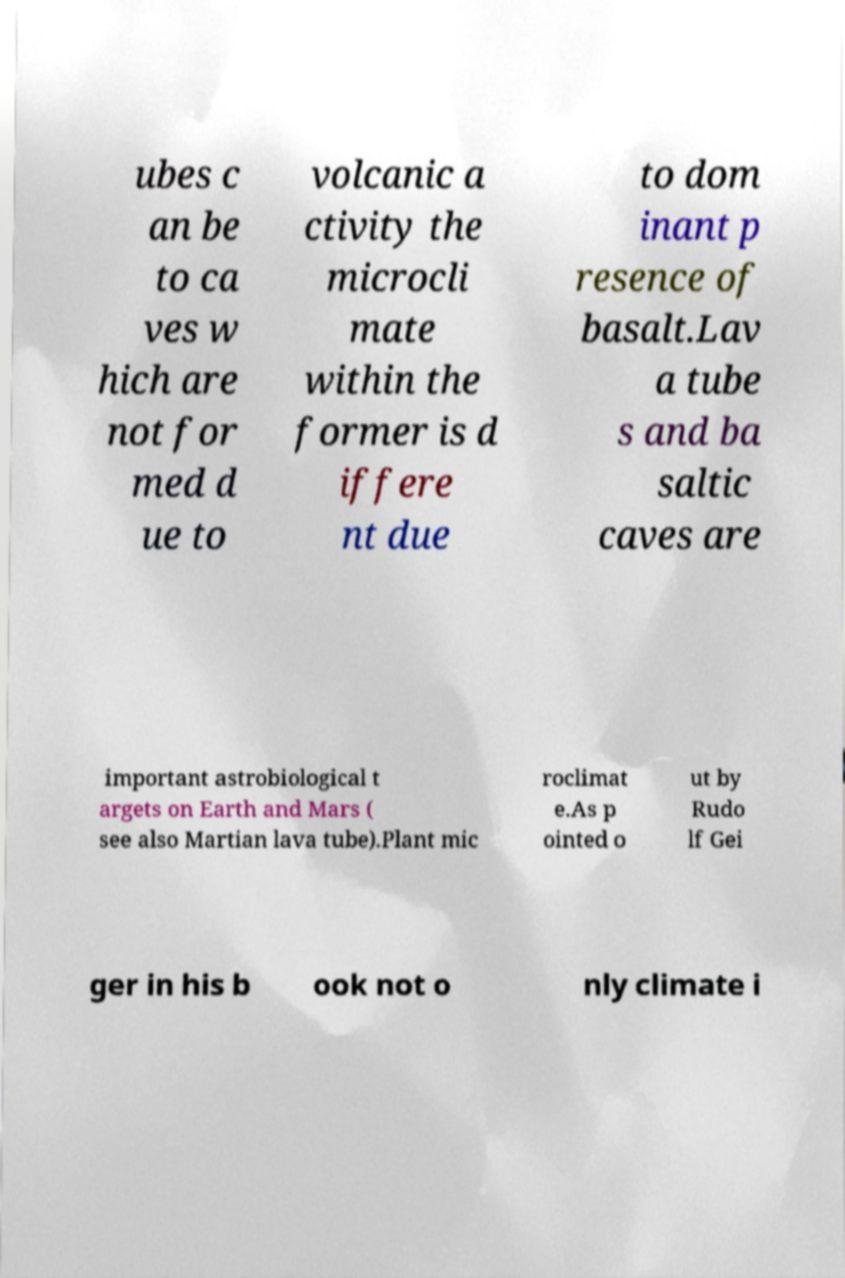Could you extract and type out the text from this image? ubes c an be to ca ves w hich are not for med d ue to volcanic a ctivity the microcli mate within the former is d iffere nt due to dom inant p resence of basalt.Lav a tube s and ba saltic caves are important astrobiological t argets on Earth and Mars ( see also Martian lava tube).Plant mic roclimat e.As p ointed o ut by Rudo lf Gei ger in his b ook not o nly climate i 